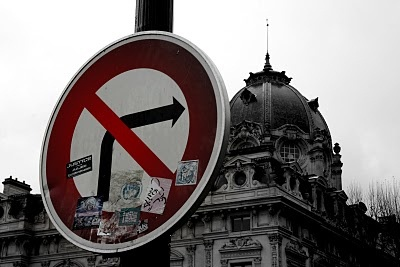Describe the objects in this image and their specific colors. I can see various objects in this image with different colors. 